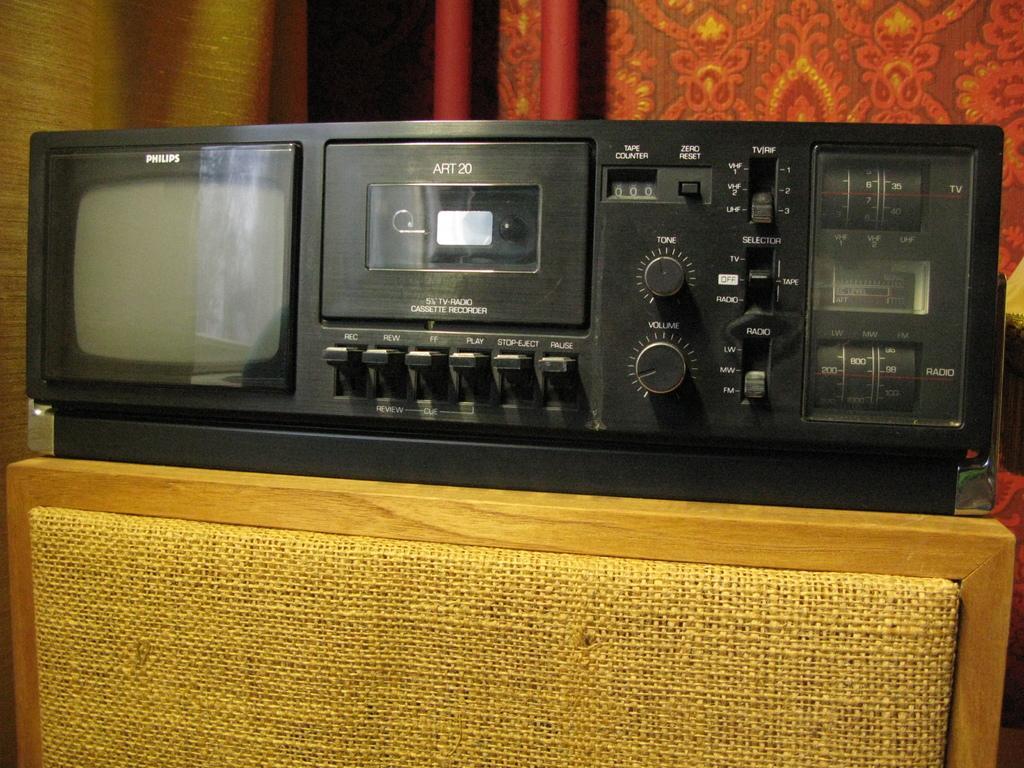Can you describe this image briefly? In this image we can see an electronic gadget on a wooden object. Behind the gadget we can see a red color object. 